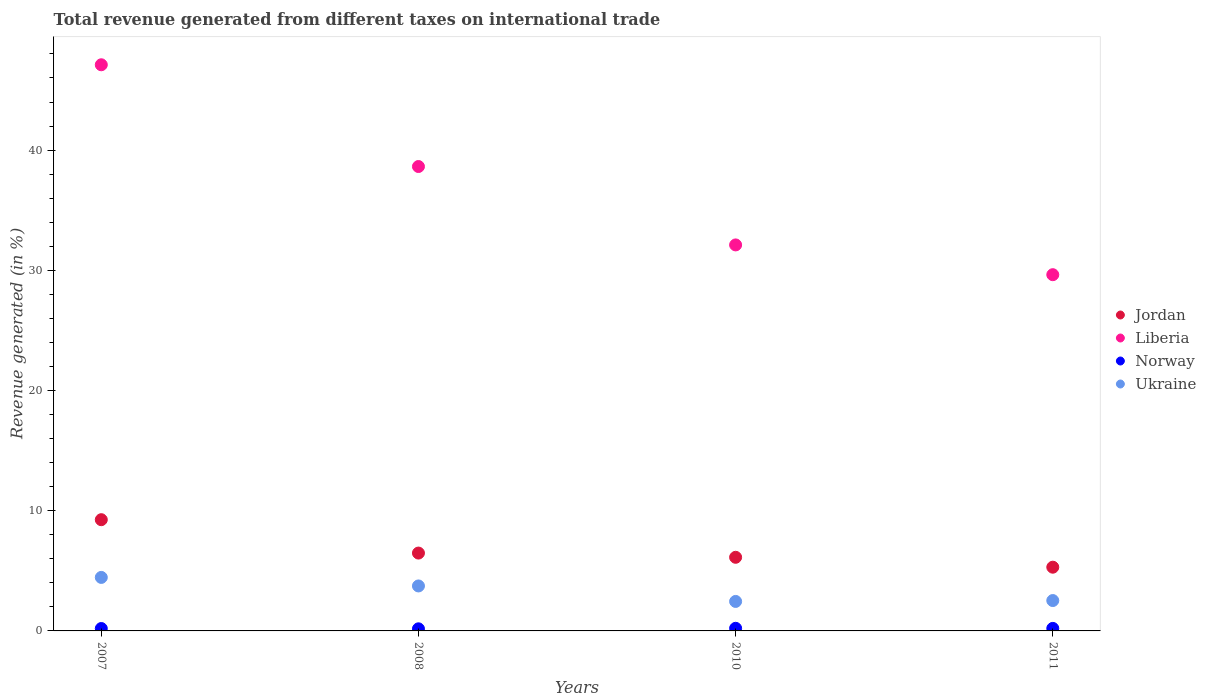Is the number of dotlines equal to the number of legend labels?
Ensure brevity in your answer.  Yes. What is the total revenue generated in Norway in 2007?
Your response must be concise. 0.2. Across all years, what is the maximum total revenue generated in Liberia?
Your answer should be very brief. 47.1. Across all years, what is the minimum total revenue generated in Jordan?
Offer a very short reply. 5.3. In which year was the total revenue generated in Jordan maximum?
Your answer should be compact. 2007. What is the total total revenue generated in Jordan in the graph?
Your answer should be very brief. 27.16. What is the difference between the total revenue generated in Liberia in 2010 and that in 2011?
Provide a succinct answer. 2.48. What is the difference between the total revenue generated in Ukraine in 2011 and the total revenue generated in Norway in 2008?
Make the answer very short. 2.35. What is the average total revenue generated in Jordan per year?
Offer a terse response. 6.79. In the year 2011, what is the difference between the total revenue generated in Norway and total revenue generated in Ukraine?
Provide a succinct answer. -2.32. In how many years, is the total revenue generated in Liberia greater than 44 %?
Your answer should be compact. 1. What is the ratio of the total revenue generated in Jordan in 2007 to that in 2008?
Ensure brevity in your answer.  1.43. Is the total revenue generated in Ukraine in 2007 less than that in 2011?
Your response must be concise. No. What is the difference between the highest and the second highest total revenue generated in Norway?
Provide a short and direct response. 0.01. What is the difference between the highest and the lowest total revenue generated in Jordan?
Ensure brevity in your answer.  3.95. In how many years, is the total revenue generated in Ukraine greater than the average total revenue generated in Ukraine taken over all years?
Make the answer very short. 2. Does the total revenue generated in Jordan monotonically increase over the years?
Give a very brief answer. No. Does the graph contain grids?
Your answer should be very brief. No. What is the title of the graph?
Keep it short and to the point. Total revenue generated from different taxes on international trade. What is the label or title of the Y-axis?
Ensure brevity in your answer.  Revenue generated (in %). What is the Revenue generated (in %) of Jordan in 2007?
Offer a very short reply. 9.25. What is the Revenue generated (in %) in Liberia in 2007?
Offer a terse response. 47.1. What is the Revenue generated (in %) of Norway in 2007?
Your answer should be very brief. 0.2. What is the Revenue generated (in %) of Ukraine in 2007?
Your response must be concise. 4.45. What is the Revenue generated (in %) of Jordan in 2008?
Make the answer very short. 6.48. What is the Revenue generated (in %) in Liberia in 2008?
Your answer should be very brief. 38.63. What is the Revenue generated (in %) of Norway in 2008?
Make the answer very short. 0.17. What is the Revenue generated (in %) of Ukraine in 2008?
Your answer should be compact. 3.74. What is the Revenue generated (in %) of Jordan in 2010?
Your answer should be very brief. 6.13. What is the Revenue generated (in %) in Liberia in 2010?
Offer a terse response. 32.11. What is the Revenue generated (in %) of Norway in 2010?
Keep it short and to the point. 0.22. What is the Revenue generated (in %) of Ukraine in 2010?
Your answer should be compact. 2.45. What is the Revenue generated (in %) in Jordan in 2011?
Make the answer very short. 5.3. What is the Revenue generated (in %) in Liberia in 2011?
Keep it short and to the point. 29.64. What is the Revenue generated (in %) of Norway in 2011?
Offer a terse response. 0.21. What is the Revenue generated (in %) in Ukraine in 2011?
Offer a terse response. 2.53. Across all years, what is the maximum Revenue generated (in %) in Jordan?
Your answer should be very brief. 9.25. Across all years, what is the maximum Revenue generated (in %) in Liberia?
Offer a terse response. 47.1. Across all years, what is the maximum Revenue generated (in %) of Norway?
Make the answer very short. 0.22. Across all years, what is the maximum Revenue generated (in %) in Ukraine?
Keep it short and to the point. 4.45. Across all years, what is the minimum Revenue generated (in %) of Jordan?
Your answer should be very brief. 5.3. Across all years, what is the minimum Revenue generated (in %) of Liberia?
Provide a succinct answer. 29.64. Across all years, what is the minimum Revenue generated (in %) in Norway?
Your answer should be very brief. 0.17. Across all years, what is the minimum Revenue generated (in %) of Ukraine?
Your response must be concise. 2.45. What is the total Revenue generated (in %) in Jordan in the graph?
Your answer should be compact. 27.16. What is the total Revenue generated (in %) of Liberia in the graph?
Ensure brevity in your answer.  147.48. What is the total Revenue generated (in %) of Norway in the graph?
Provide a short and direct response. 0.8. What is the total Revenue generated (in %) of Ukraine in the graph?
Provide a short and direct response. 13.17. What is the difference between the Revenue generated (in %) in Jordan in 2007 and that in 2008?
Offer a very short reply. 2.78. What is the difference between the Revenue generated (in %) in Liberia in 2007 and that in 2008?
Provide a succinct answer. 8.46. What is the difference between the Revenue generated (in %) of Norway in 2007 and that in 2008?
Keep it short and to the point. 0.02. What is the difference between the Revenue generated (in %) of Ukraine in 2007 and that in 2008?
Provide a short and direct response. 0.71. What is the difference between the Revenue generated (in %) of Jordan in 2007 and that in 2010?
Your answer should be compact. 3.13. What is the difference between the Revenue generated (in %) in Liberia in 2007 and that in 2010?
Your answer should be compact. 14.99. What is the difference between the Revenue generated (in %) in Norway in 2007 and that in 2010?
Give a very brief answer. -0.02. What is the difference between the Revenue generated (in %) in Ukraine in 2007 and that in 2010?
Offer a terse response. 2. What is the difference between the Revenue generated (in %) in Jordan in 2007 and that in 2011?
Your response must be concise. 3.95. What is the difference between the Revenue generated (in %) in Liberia in 2007 and that in 2011?
Keep it short and to the point. 17.46. What is the difference between the Revenue generated (in %) in Norway in 2007 and that in 2011?
Offer a very short reply. -0.01. What is the difference between the Revenue generated (in %) of Ukraine in 2007 and that in 2011?
Provide a succinct answer. 1.92. What is the difference between the Revenue generated (in %) of Jordan in 2008 and that in 2010?
Offer a terse response. 0.35. What is the difference between the Revenue generated (in %) of Liberia in 2008 and that in 2010?
Your answer should be compact. 6.52. What is the difference between the Revenue generated (in %) in Norway in 2008 and that in 2010?
Give a very brief answer. -0.04. What is the difference between the Revenue generated (in %) in Ukraine in 2008 and that in 2010?
Your answer should be very brief. 1.29. What is the difference between the Revenue generated (in %) in Jordan in 2008 and that in 2011?
Give a very brief answer. 1.18. What is the difference between the Revenue generated (in %) of Liberia in 2008 and that in 2011?
Make the answer very short. 9. What is the difference between the Revenue generated (in %) of Norway in 2008 and that in 2011?
Ensure brevity in your answer.  -0.04. What is the difference between the Revenue generated (in %) in Ukraine in 2008 and that in 2011?
Offer a very short reply. 1.21. What is the difference between the Revenue generated (in %) of Jordan in 2010 and that in 2011?
Provide a short and direct response. 0.82. What is the difference between the Revenue generated (in %) of Liberia in 2010 and that in 2011?
Offer a terse response. 2.48. What is the difference between the Revenue generated (in %) in Norway in 2010 and that in 2011?
Provide a short and direct response. 0.01. What is the difference between the Revenue generated (in %) in Ukraine in 2010 and that in 2011?
Provide a short and direct response. -0.07. What is the difference between the Revenue generated (in %) of Jordan in 2007 and the Revenue generated (in %) of Liberia in 2008?
Your answer should be very brief. -29.38. What is the difference between the Revenue generated (in %) in Jordan in 2007 and the Revenue generated (in %) in Norway in 2008?
Your response must be concise. 9.08. What is the difference between the Revenue generated (in %) of Jordan in 2007 and the Revenue generated (in %) of Ukraine in 2008?
Your answer should be very brief. 5.51. What is the difference between the Revenue generated (in %) of Liberia in 2007 and the Revenue generated (in %) of Norway in 2008?
Provide a short and direct response. 46.92. What is the difference between the Revenue generated (in %) in Liberia in 2007 and the Revenue generated (in %) in Ukraine in 2008?
Offer a very short reply. 43.36. What is the difference between the Revenue generated (in %) of Norway in 2007 and the Revenue generated (in %) of Ukraine in 2008?
Keep it short and to the point. -3.54. What is the difference between the Revenue generated (in %) of Jordan in 2007 and the Revenue generated (in %) of Liberia in 2010?
Ensure brevity in your answer.  -22.86. What is the difference between the Revenue generated (in %) in Jordan in 2007 and the Revenue generated (in %) in Norway in 2010?
Offer a very short reply. 9.04. What is the difference between the Revenue generated (in %) of Jordan in 2007 and the Revenue generated (in %) of Ukraine in 2010?
Provide a short and direct response. 6.8. What is the difference between the Revenue generated (in %) in Liberia in 2007 and the Revenue generated (in %) in Norway in 2010?
Provide a succinct answer. 46.88. What is the difference between the Revenue generated (in %) of Liberia in 2007 and the Revenue generated (in %) of Ukraine in 2010?
Ensure brevity in your answer.  44.65. What is the difference between the Revenue generated (in %) of Norway in 2007 and the Revenue generated (in %) of Ukraine in 2010?
Your answer should be compact. -2.25. What is the difference between the Revenue generated (in %) of Jordan in 2007 and the Revenue generated (in %) of Liberia in 2011?
Provide a succinct answer. -20.38. What is the difference between the Revenue generated (in %) in Jordan in 2007 and the Revenue generated (in %) in Norway in 2011?
Provide a succinct answer. 9.04. What is the difference between the Revenue generated (in %) of Jordan in 2007 and the Revenue generated (in %) of Ukraine in 2011?
Offer a terse response. 6.73. What is the difference between the Revenue generated (in %) of Liberia in 2007 and the Revenue generated (in %) of Norway in 2011?
Provide a succinct answer. 46.89. What is the difference between the Revenue generated (in %) in Liberia in 2007 and the Revenue generated (in %) in Ukraine in 2011?
Provide a short and direct response. 44.57. What is the difference between the Revenue generated (in %) in Norway in 2007 and the Revenue generated (in %) in Ukraine in 2011?
Give a very brief answer. -2.33. What is the difference between the Revenue generated (in %) in Jordan in 2008 and the Revenue generated (in %) in Liberia in 2010?
Your answer should be very brief. -25.64. What is the difference between the Revenue generated (in %) in Jordan in 2008 and the Revenue generated (in %) in Norway in 2010?
Your answer should be very brief. 6.26. What is the difference between the Revenue generated (in %) in Jordan in 2008 and the Revenue generated (in %) in Ukraine in 2010?
Ensure brevity in your answer.  4.02. What is the difference between the Revenue generated (in %) of Liberia in 2008 and the Revenue generated (in %) of Norway in 2010?
Ensure brevity in your answer.  38.42. What is the difference between the Revenue generated (in %) in Liberia in 2008 and the Revenue generated (in %) in Ukraine in 2010?
Offer a very short reply. 36.18. What is the difference between the Revenue generated (in %) of Norway in 2008 and the Revenue generated (in %) of Ukraine in 2010?
Your answer should be compact. -2.28. What is the difference between the Revenue generated (in %) of Jordan in 2008 and the Revenue generated (in %) of Liberia in 2011?
Your answer should be very brief. -23.16. What is the difference between the Revenue generated (in %) of Jordan in 2008 and the Revenue generated (in %) of Norway in 2011?
Provide a short and direct response. 6.27. What is the difference between the Revenue generated (in %) of Jordan in 2008 and the Revenue generated (in %) of Ukraine in 2011?
Provide a succinct answer. 3.95. What is the difference between the Revenue generated (in %) of Liberia in 2008 and the Revenue generated (in %) of Norway in 2011?
Your response must be concise. 38.42. What is the difference between the Revenue generated (in %) of Liberia in 2008 and the Revenue generated (in %) of Ukraine in 2011?
Your response must be concise. 36.11. What is the difference between the Revenue generated (in %) in Norway in 2008 and the Revenue generated (in %) in Ukraine in 2011?
Provide a short and direct response. -2.35. What is the difference between the Revenue generated (in %) in Jordan in 2010 and the Revenue generated (in %) in Liberia in 2011?
Your answer should be compact. -23.51. What is the difference between the Revenue generated (in %) in Jordan in 2010 and the Revenue generated (in %) in Norway in 2011?
Give a very brief answer. 5.91. What is the difference between the Revenue generated (in %) in Jordan in 2010 and the Revenue generated (in %) in Ukraine in 2011?
Provide a short and direct response. 3.6. What is the difference between the Revenue generated (in %) of Liberia in 2010 and the Revenue generated (in %) of Norway in 2011?
Provide a short and direct response. 31.9. What is the difference between the Revenue generated (in %) of Liberia in 2010 and the Revenue generated (in %) of Ukraine in 2011?
Keep it short and to the point. 29.59. What is the difference between the Revenue generated (in %) of Norway in 2010 and the Revenue generated (in %) of Ukraine in 2011?
Offer a very short reply. -2.31. What is the average Revenue generated (in %) of Jordan per year?
Provide a succinct answer. 6.79. What is the average Revenue generated (in %) in Liberia per year?
Make the answer very short. 36.87. What is the average Revenue generated (in %) in Norway per year?
Offer a terse response. 0.2. What is the average Revenue generated (in %) in Ukraine per year?
Offer a terse response. 3.29. In the year 2007, what is the difference between the Revenue generated (in %) of Jordan and Revenue generated (in %) of Liberia?
Give a very brief answer. -37.85. In the year 2007, what is the difference between the Revenue generated (in %) of Jordan and Revenue generated (in %) of Norway?
Keep it short and to the point. 9.05. In the year 2007, what is the difference between the Revenue generated (in %) in Jordan and Revenue generated (in %) in Ukraine?
Ensure brevity in your answer.  4.8. In the year 2007, what is the difference between the Revenue generated (in %) in Liberia and Revenue generated (in %) in Norway?
Provide a succinct answer. 46.9. In the year 2007, what is the difference between the Revenue generated (in %) of Liberia and Revenue generated (in %) of Ukraine?
Your response must be concise. 42.65. In the year 2007, what is the difference between the Revenue generated (in %) of Norway and Revenue generated (in %) of Ukraine?
Your answer should be compact. -4.25. In the year 2008, what is the difference between the Revenue generated (in %) in Jordan and Revenue generated (in %) in Liberia?
Give a very brief answer. -32.16. In the year 2008, what is the difference between the Revenue generated (in %) of Jordan and Revenue generated (in %) of Norway?
Provide a succinct answer. 6.3. In the year 2008, what is the difference between the Revenue generated (in %) in Jordan and Revenue generated (in %) in Ukraine?
Your answer should be very brief. 2.74. In the year 2008, what is the difference between the Revenue generated (in %) in Liberia and Revenue generated (in %) in Norway?
Provide a succinct answer. 38.46. In the year 2008, what is the difference between the Revenue generated (in %) in Liberia and Revenue generated (in %) in Ukraine?
Keep it short and to the point. 34.89. In the year 2008, what is the difference between the Revenue generated (in %) in Norway and Revenue generated (in %) in Ukraine?
Provide a short and direct response. -3.57. In the year 2010, what is the difference between the Revenue generated (in %) of Jordan and Revenue generated (in %) of Liberia?
Offer a very short reply. -25.99. In the year 2010, what is the difference between the Revenue generated (in %) of Jordan and Revenue generated (in %) of Norway?
Your answer should be very brief. 5.91. In the year 2010, what is the difference between the Revenue generated (in %) of Jordan and Revenue generated (in %) of Ukraine?
Offer a very short reply. 3.67. In the year 2010, what is the difference between the Revenue generated (in %) of Liberia and Revenue generated (in %) of Norway?
Make the answer very short. 31.89. In the year 2010, what is the difference between the Revenue generated (in %) in Liberia and Revenue generated (in %) in Ukraine?
Provide a succinct answer. 29.66. In the year 2010, what is the difference between the Revenue generated (in %) in Norway and Revenue generated (in %) in Ukraine?
Your response must be concise. -2.24. In the year 2011, what is the difference between the Revenue generated (in %) in Jordan and Revenue generated (in %) in Liberia?
Your response must be concise. -24.33. In the year 2011, what is the difference between the Revenue generated (in %) of Jordan and Revenue generated (in %) of Norway?
Offer a terse response. 5.09. In the year 2011, what is the difference between the Revenue generated (in %) in Jordan and Revenue generated (in %) in Ukraine?
Offer a very short reply. 2.77. In the year 2011, what is the difference between the Revenue generated (in %) in Liberia and Revenue generated (in %) in Norway?
Keep it short and to the point. 29.43. In the year 2011, what is the difference between the Revenue generated (in %) in Liberia and Revenue generated (in %) in Ukraine?
Provide a short and direct response. 27.11. In the year 2011, what is the difference between the Revenue generated (in %) in Norway and Revenue generated (in %) in Ukraine?
Your answer should be very brief. -2.32. What is the ratio of the Revenue generated (in %) in Jordan in 2007 to that in 2008?
Your answer should be very brief. 1.43. What is the ratio of the Revenue generated (in %) in Liberia in 2007 to that in 2008?
Give a very brief answer. 1.22. What is the ratio of the Revenue generated (in %) in Norway in 2007 to that in 2008?
Keep it short and to the point. 1.14. What is the ratio of the Revenue generated (in %) of Ukraine in 2007 to that in 2008?
Offer a very short reply. 1.19. What is the ratio of the Revenue generated (in %) in Jordan in 2007 to that in 2010?
Your answer should be compact. 1.51. What is the ratio of the Revenue generated (in %) in Liberia in 2007 to that in 2010?
Keep it short and to the point. 1.47. What is the ratio of the Revenue generated (in %) of Norway in 2007 to that in 2010?
Keep it short and to the point. 0.91. What is the ratio of the Revenue generated (in %) of Ukraine in 2007 to that in 2010?
Make the answer very short. 1.81. What is the ratio of the Revenue generated (in %) in Jordan in 2007 to that in 2011?
Your answer should be compact. 1.75. What is the ratio of the Revenue generated (in %) in Liberia in 2007 to that in 2011?
Provide a succinct answer. 1.59. What is the ratio of the Revenue generated (in %) in Norway in 2007 to that in 2011?
Keep it short and to the point. 0.95. What is the ratio of the Revenue generated (in %) of Ukraine in 2007 to that in 2011?
Ensure brevity in your answer.  1.76. What is the ratio of the Revenue generated (in %) in Jordan in 2008 to that in 2010?
Give a very brief answer. 1.06. What is the ratio of the Revenue generated (in %) in Liberia in 2008 to that in 2010?
Your response must be concise. 1.2. What is the ratio of the Revenue generated (in %) in Norway in 2008 to that in 2010?
Offer a very short reply. 0.8. What is the ratio of the Revenue generated (in %) in Ukraine in 2008 to that in 2010?
Give a very brief answer. 1.52. What is the ratio of the Revenue generated (in %) in Jordan in 2008 to that in 2011?
Your response must be concise. 1.22. What is the ratio of the Revenue generated (in %) in Liberia in 2008 to that in 2011?
Offer a terse response. 1.3. What is the ratio of the Revenue generated (in %) of Norway in 2008 to that in 2011?
Provide a short and direct response. 0.83. What is the ratio of the Revenue generated (in %) of Ukraine in 2008 to that in 2011?
Offer a terse response. 1.48. What is the ratio of the Revenue generated (in %) in Jordan in 2010 to that in 2011?
Offer a terse response. 1.16. What is the ratio of the Revenue generated (in %) of Liberia in 2010 to that in 2011?
Your answer should be very brief. 1.08. What is the ratio of the Revenue generated (in %) of Norway in 2010 to that in 2011?
Your answer should be very brief. 1.03. What is the ratio of the Revenue generated (in %) of Ukraine in 2010 to that in 2011?
Your response must be concise. 0.97. What is the difference between the highest and the second highest Revenue generated (in %) in Jordan?
Keep it short and to the point. 2.78. What is the difference between the highest and the second highest Revenue generated (in %) of Liberia?
Give a very brief answer. 8.46. What is the difference between the highest and the second highest Revenue generated (in %) of Norway?
Your response must be concise. 0.01. What is the difference between the highest and the second highest Revenue generated (in %) of Ukraine?
Give a very brief answer. 0.71. What is the difference between the highest and the lowest Revenue generated (in %) of Jordan?
Your response must be concise. 3.95. What is the difference between the highest and the lowest Revenue generated (in %) of Liberia?
Provide a succinct answer. 17.46. What is the difference between the highest and the lowest Revenue generated (in %) of Norway?
Your answer should be very brief. 0.04. What is the difference between the highest and the lowest Revenue generated (in %) in Ukraine?
Your answer should be compact. 2. 